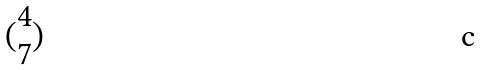<formula> <loc_0><loc_0><loc_500><loc_500>( \begin{matrix} 4 \\ 7 \end{matrix} )</formula> 